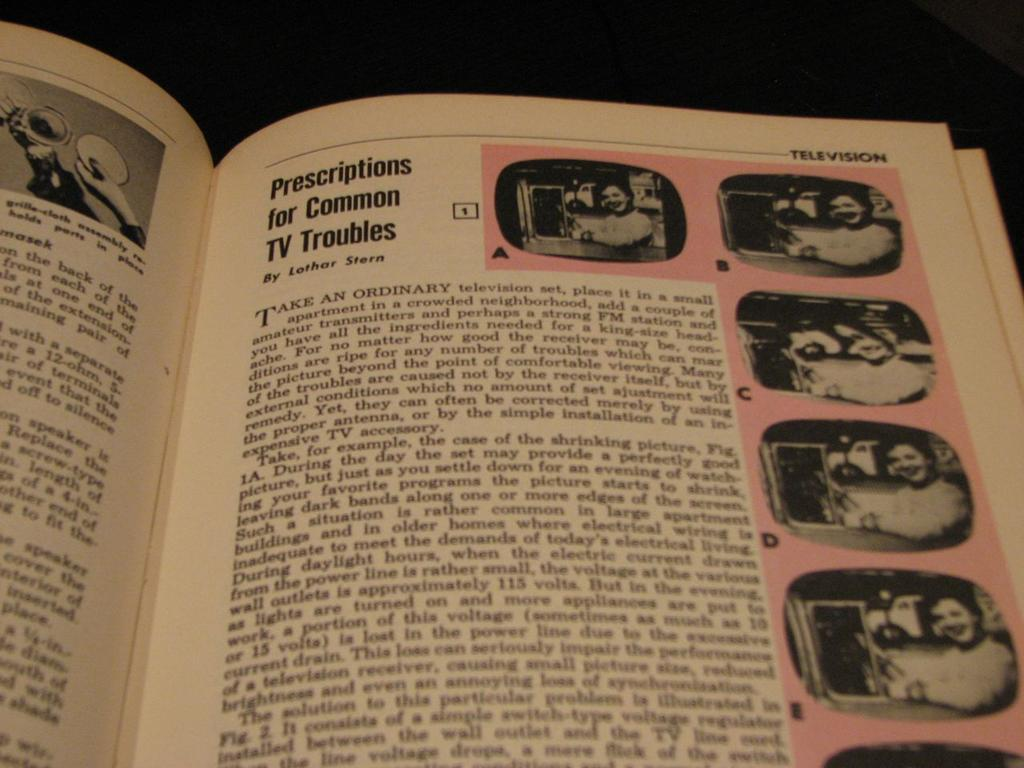<image>
Provide a brief description of the given image. A book is open to a page about solving TV troubles with images of a woman by a tv on the edge of the page. 